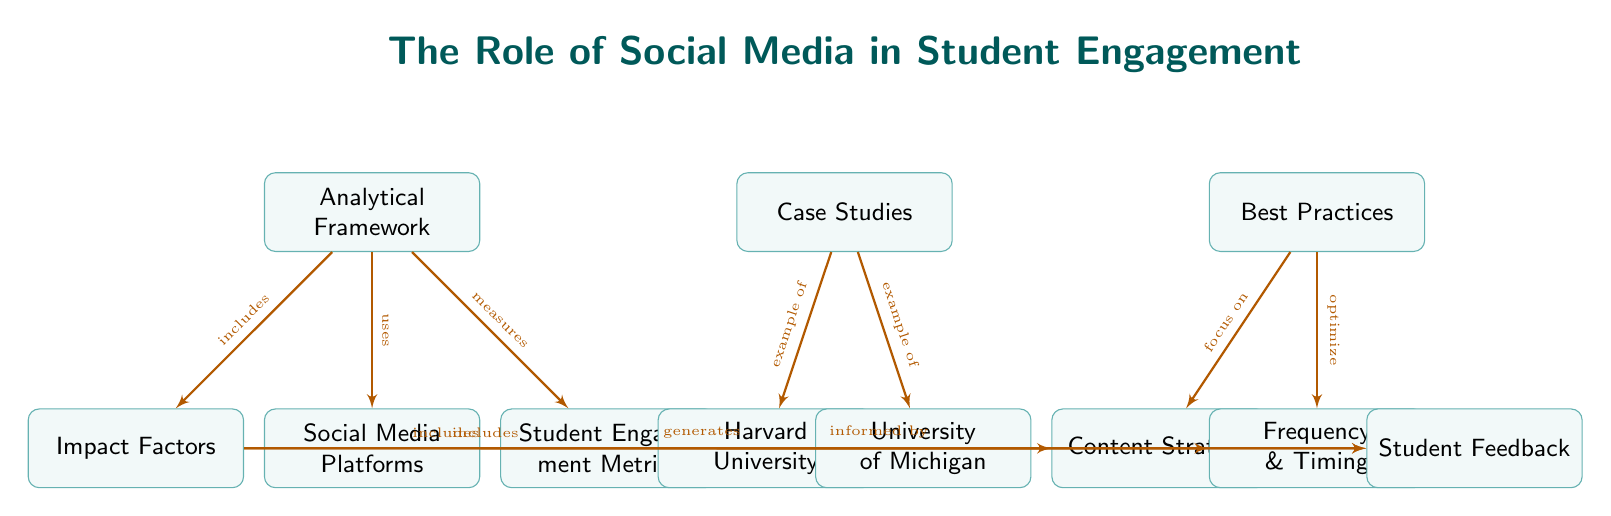What are the three main components illustrated in the diagram? The diagram contains three main components: Analytical Framework, Case Studies, and Best Practices. These can be identified as the top-level boxes in the diagram.
Answer: Analytical Framework, Case Studies, Best Practices Which social media platform is used for generating student feedback? The diagram indicates that social media platforms generate student feedback, positioned as a connection from the "Social Media Platforms" node to the "Student Feedback" node.
Answer: Social Media Platforms How many case studies are presented in the diagram? The diagram shows two case studies, represented by nodes for Harvard University and University of Michigan connected under the Case Studies component.
Answer: 2 What is the relationship between Impact Factors and Content Strategy? The diagram illustrates that Impact Factors include Content Strategy, shown by the arrow connecting these two nodes.
Answer: includes What do Best Practices focus on according to the diagram? The diagram indicates that Best Practices focus on Content Strategy, as represented by the arrow connecting the Best Practices node to the Content Strategy node.
Answer: Content Strategy Explain how Student Engagement Metrics are informed by Student Feedback. The diagram shows that Student Engagement Metrics are informed by Student Feedback, denoted by a connection from the "Student Engagement Metrics" node to the "Student Feedback" node. This indicates that feedback from students can help shape engagement metrics.
Answer: informed by What two aspects of social media are included under the Analytical Framework? The diagram indicates that the Analytical Framework includes social media platforms and impact factors, as shown by the arrows leading from the Analytical Framework node to these two nodes.
Answer: Social Media Platforms, Impact Factors Which node connects to both Harvard University and University of Michigan? The diagram indicates that both Harvard University and University of Michigan connect to the Case Studies node, demonstrating that they serve as examples of case studies within this framework.
Answer: Case Studies What is highlighted as a key metric within the Analytical Framework? The diagram highlights Student Engagement Metrics as a key metric within the Analytical Framework, indicated by the arrow leading from the Analytical Framework to the Student Engagement Metrics node.
Answer: Student Engagement Metrics 